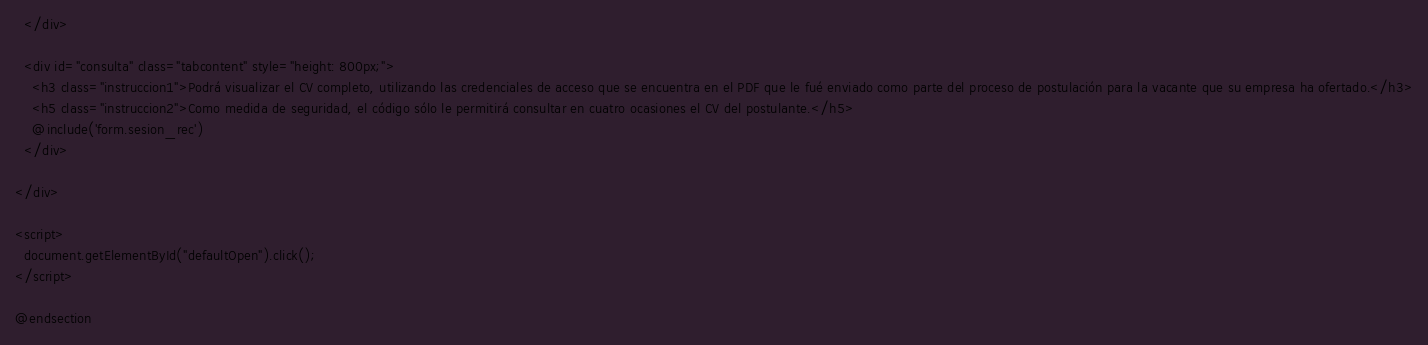Convert code to text. <code><loc_0><loc_0><loc_500><loc_500><_PHP_>  </div>

  <div id="consulta" class="tabcontent" style="height: 800px;">
    <h3 class="instruccion1">Podrá visualizar el CV completo, utilizando las credenciales de acceso que se encuentra en el PDF que le fué enviado como parte del proceso de postulación para la vacante que su empresa ha ofertado.</h3>
    <h5 class="instruccion2">Como medida de seguridad, el código sólo le permitirá consultar en cuatro ocasiones el CV del postulante.</h5>
    @include('form.sesion_rec')
  </div>

</div>

<script>
  document.getElementById("defaultOpen").click();
</script>

@endsection</code> 